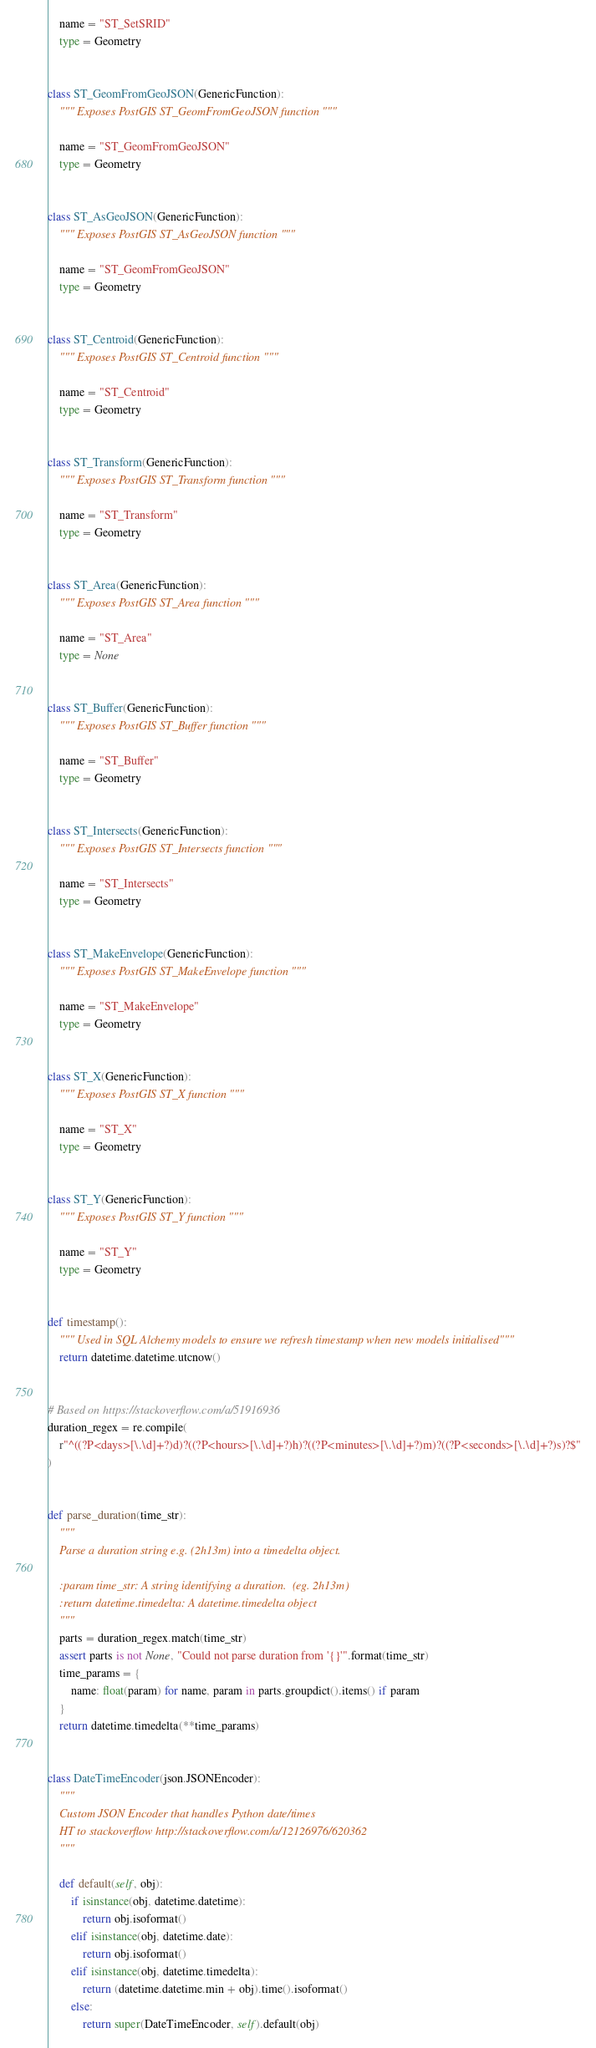Convert code to text. <code><loc_0><loc_0><loc_500><loc_500><_Python_>    name = "ST_SetSRID"
    type = Geometry


class ST_GeomFromGeoJSON(GenericFunction):
    """ Exposes PostGIS ST_GeomFromGeoJSON function """

    name = "ST_GeomFromGeoJSON"
    type = Geometry


class ST_AsGeoJSON(GenericFunction):
    """ Exposes PostGIS ST_AsGeoJSON function """

    name = "ST_GeomFromGeoJSON"
    type = Geometry


class ST_Centroid(GenericFunction):
    """ Exposes PostGIS ST_Centroid function """

    name = "ST_Centroid"
    type = Geometry


class ST_Transform(GenericFunction):
    """ Exposes PostGIS ST_Transform function """

    name = "ST_Transform"
    type = Geometry


class ST_Area(GenericFunction):
    """ Exposes PostGIS ST_Area function """

    name = "ST_Area"
    type = None


class ST_Buffer(GenericFunction):
    """ Exposes PostGIS ST_Buffer function """

    name = "ST_Buffer"
    type = Geometry


class ST_Intersects(GenericFunction):
    """ Exposes PostGIS ST_Intersects function """

    name = "ST_Intersects"
    type = Geometry


class ST_MakeEnvelope(GenericFunction):
    """ Exposes PostGIS ST_MakeEnvelope function """

    name = "ST_MakeEnvelope"
    type = Geometry


class ST_X(GenericFunction):
    """ Exposes PostGIS ST_X function """

    name = "ST_X"
    type = Geometry


class ST_Y(GenericFunction):
    """ Exposes PostGIS ST_Y function """

    name = "ST_Y"
    type = Geometry


def timestamp():
    """ Used in SQL Alchemy models to ensure we refresh timestamp when new models initialised"""
    return datetime.datetime.utcnow()


# Based on https://stackoverflow.com/a/51916936
duration_regex = re.compile(
    r"^((?P<days>[\.\d]+?)d)?((?P<hours>[\.\d]+?)h)?((?P<minutes>[\.\d]+?)m)?((?P<seconds>[\.\d]+?)s)?$"
)


def parse_duration(time_str):
    """
    Parse a duration string e.g. (2h13m) into a timedelta object.

    :param time_str: A string identifying a duration.  (eg. 2h13m)
    :return datetime.timedelta: A datetime.timedelta object
    """
    parts = duration_regex.match(time_str)
    assert parts is not None, "Could not parse duration from '{}'".format(time_str)
    time_params = {
        name: float(param) for name, param in parts.groupdict().items() if param
    }
    return datetime.timedelta(**time_params)


class DateTimeEncoder(json.JSONEncoder):
    """
    Custom JSON Encoder that handles Python date/times
    HT to stackoverflow http://stackoverflow.com/a/12126976/620362
    """

    def default(self, obj):
        if isinstance(obj, datetime.datetime):
            return obj.isoformat()
        elif isinstance(obj, datetime.date):
            return obj.isoformat()
        elif isinstance(obj, datetime.timedelta):
            return (datetime.datetime.min + obj).time().isoformat()
        else:
            return super(DateTimeEncoder, self).default(obj)
</code> 